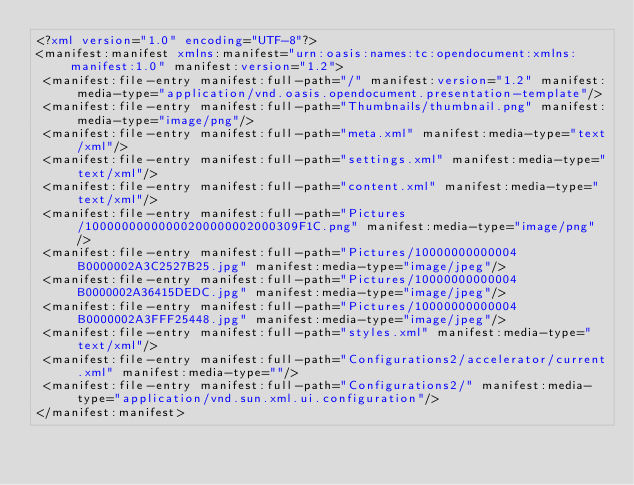<code> <loc_0><loc_0><loc_500><loc_500><_XML_><?xml version="1.0" encoding="UTF-8"?>
<manifest:manifest xmlns:manifest="urn:oasis:names:tc:opendocument:xmlns:manifest:1.0" manifest:version="1.2">
 <manifest:file-entry manifest:full-path="/" manifest:version="1.2" manifest:media-type="application/vnd.oasis.opendocument.presentation-template"/>
 <manifest:file-entry manifest:full-path="Thumbnails/thumbnail.png" manifest:media-type="image/png"/>
 <manifest:file-entry manifest:full-path="meta.xml" manifest:media-type="text/xml"/>
 <manifest:file-entry manifest:full-path="settings.xml" manifest:media-type="text/xml"/>
 <manifest:file-entry manifest:full-path="content.xml" manifest:media-type="text/xml"/>
 <manifest:file-entry manifest:full-path="Pictures/10000000000000200000002000309F1C.png" manifest:media-type="image/png"/>
 <manifest:file-entry manifest:full-path="Pictures/10000000000004B0000002A3C2527B25.jpg" manifest:media-type="image/jpeg"/>
 <manifest:file-entry manifest:full-path="Pictures/10000000000004B0000002A36415DEDC.jpg" manifest:media-type="image/jpeg"/>
 <manifest:file-entry manifest:full-path="Pictures/10000000000004B0000002A3FFF25448.jpg" manifest:media-type="image/jpeg"/>
 <manifest:file-entry manifest:full-path="styles.xml" manifest:media-type="text/xml"/>
 <manifest:file-entry manifest:full-path="Configurations2/accelerator/current.xml" manifest:media-type=""/>
 <manifest:file-entry manifest:full-path="Configurations2/" manifest:media-type="application/vnd.sun.xml.ui.configuration"/>
</manifest:manifest></code> 